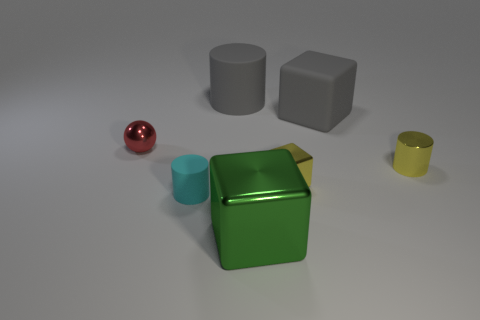What number of other objects are the same color as the big matte cylinder?
Ensure brevity in your answer.  1. Does the gray thing right of the big shiny thing have the same material as the big green cube?
Provide a succinct answer. No. What is the cylinder in front of the yellow cylinder made of?
Offer a terse response. Rubber. How big is the gray thing that is behind the big gray rubber object that is right of the green block?
Offer a terse response. Large. Is there a small red thing made of the same material as the yellow cylinder?
Your answer should be compact. Yes. There is a large gray rubber thing that is right of the big cube that is in front of the small shiny thing left of the cyan rubber cylinder; what is its shape?
Your answer should be very brief. Cube. There is a large thing to the left of the green metal cube; does it have the same color as the shiny thing behind the small yellow cylinder?
Offer a terse response. No. Are there any other things that are the same size as the gray rubber cube?
Your answer should be compact. Yes. Are there any small yellow things in front of the yellow cube?
Ensure brevity in your answer.  No. How many red shiny things are the same shape as the large green thing?
Provide a succinct answer. 0. 